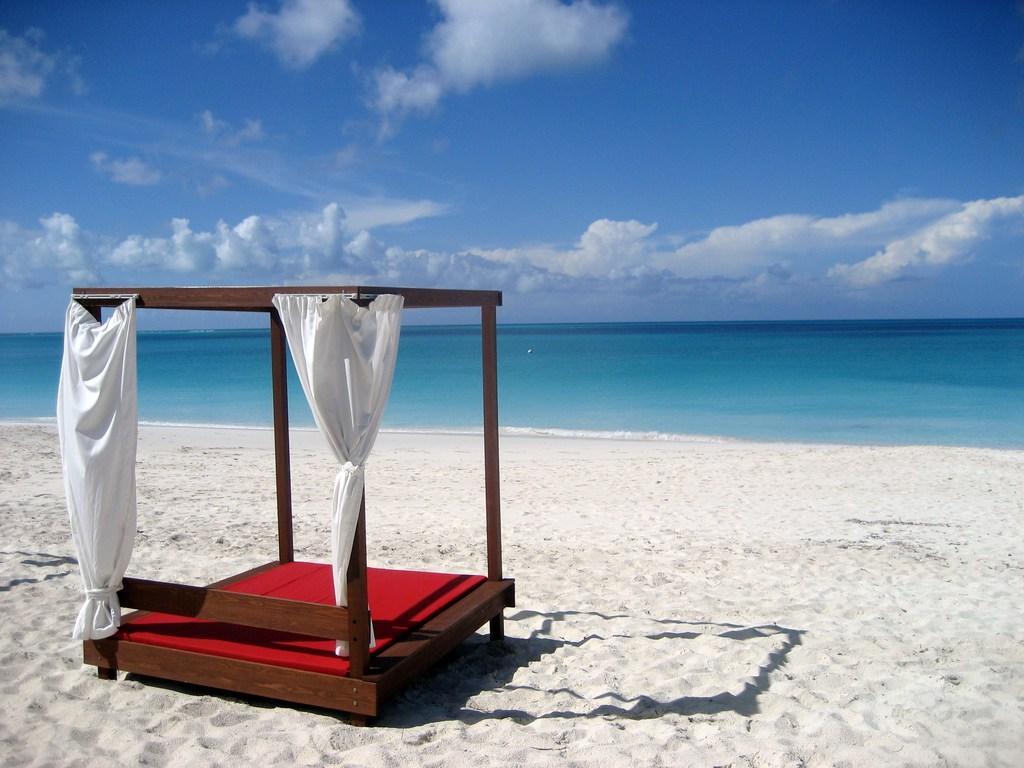Can you describe this image briefly? In this picture I can see there is a bed and it has a curtain and there is sand on the floor, in the backdrop there is an ocean and the sky is clear. 